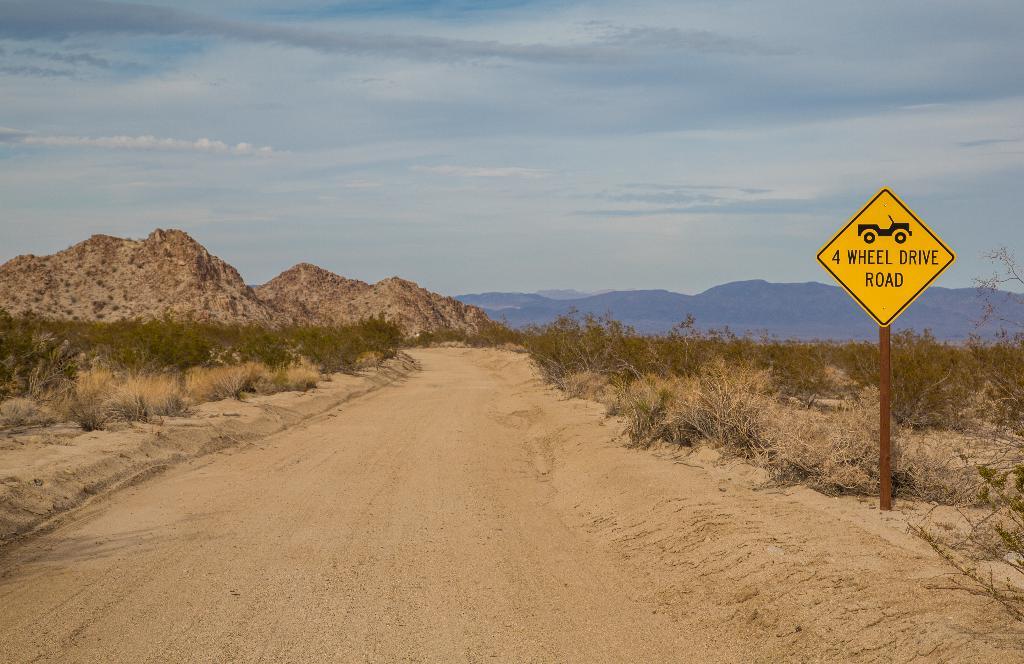What does the sign say?
Give a very brief answer. 4 wheel drive road. What do you need to drive this road?
Offer a terse response. 4 wheel drive. 